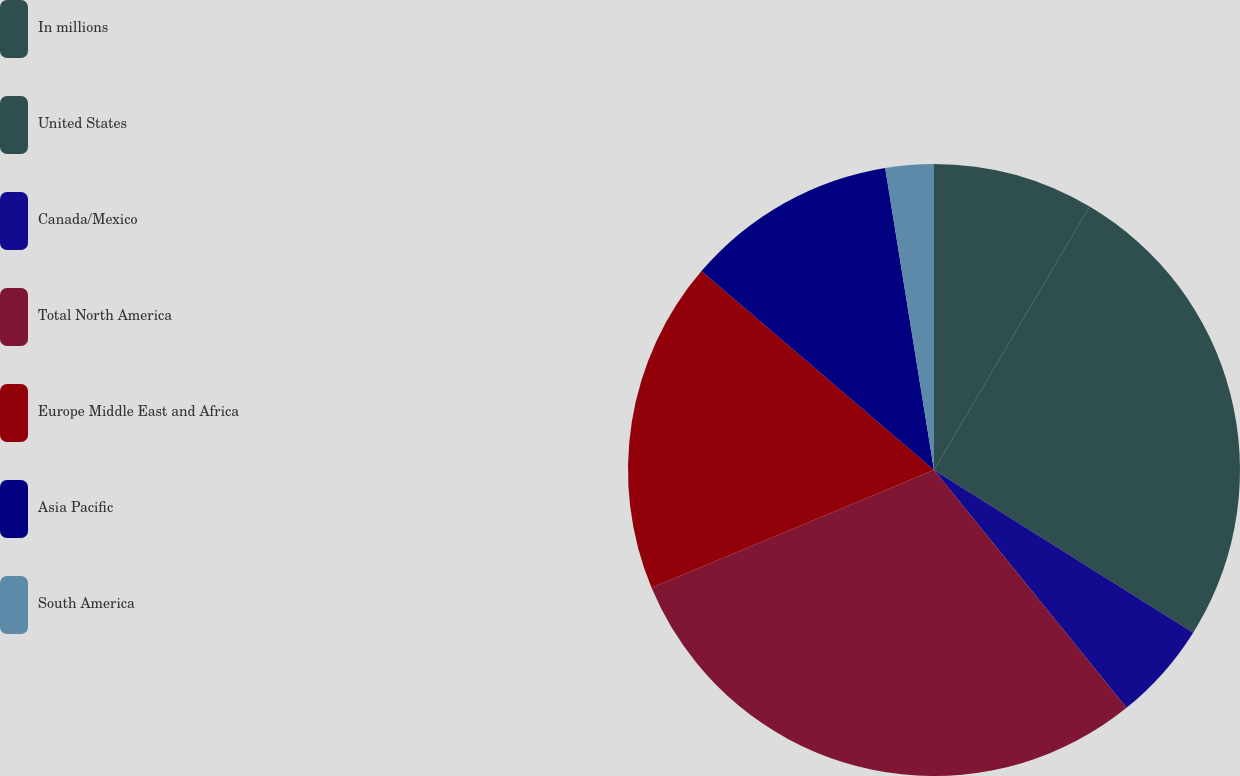<chart> <loc_0><loc_0><loc_500><loc_500><pie_chart><fcel>In millions<fcel>United States<fcel>Canada/Mexico<fcel>Total North America<fcel>Europe Middle East and Africa<fcel>Asia Pacific<fcel>South America<nl><fcel>8.49%<fcel>25.43%<fcel>5.25%<fcel>29.54%<fcel>17.55%<fcel>11.19%<fcel>2.55%<nl></chart> 